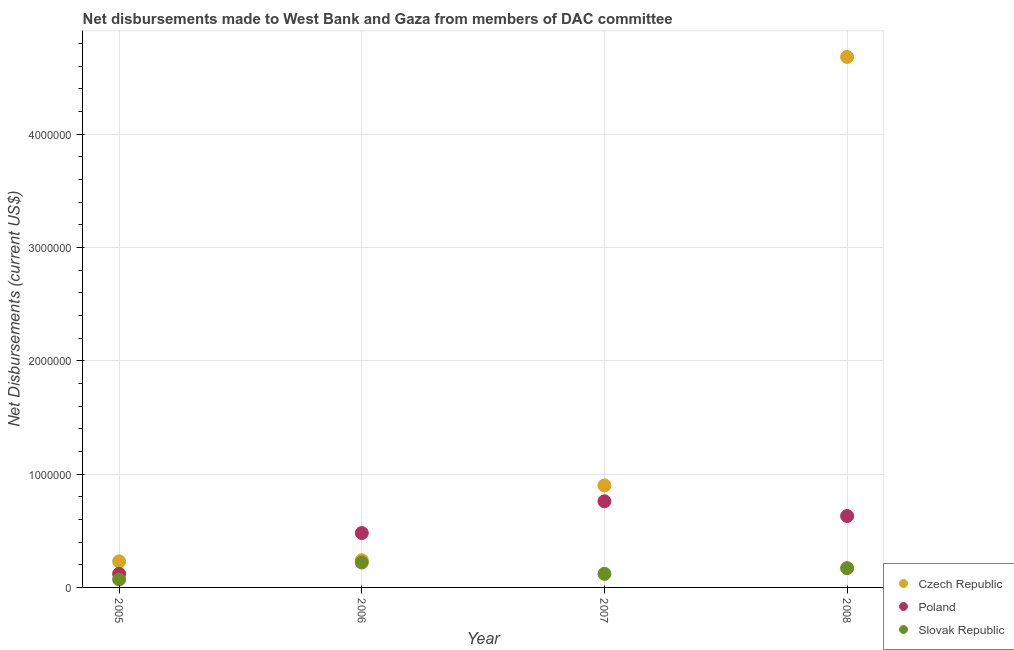How many different coloured dotlines are there?
Offer a very short reply. 3. Is the number of dotlines equal to the number of legend labels?
Offer a very short reply. Yes. What is the net disbursements made by slovak republic in 2006?
Keep it short and to the point. 2.20e+05. Across all years, what is the maximum net disbursements made by slovak republic?
Your answer should be compact. 2.20e+05. Across all years, what is the minimum net disbursements made by poland?
Offer a terse response. 1.20e+05. In which year was the net disbursements made by poland minimum?
Offer a terse response. 2005. What is the total net disbursements made by slovak republic in the graph?
Give a very brief answer. 5.80e+05. What is the difference between the net disbursements made by poland in 2007 and that in 2008?
Your response must be concise. 1.30e+05. What is the difference between the net disbursements made by czech republic in 2007 and the net disbursements made by poland in 2006?
Provide a short and direct response. 4.20e+05. What is the average net disbursements made by slovak republic per year?
Provide a succinct answer. 1.45e+05. In the year 2008, what is the difference between the net disbursements made by poland and net disbursements made by czech republic?
Give a very brief answer. -4.05e+06. What is the ratio of the net disbursements made by poland in 2005 to that in 2008?
Ensure brevity in your answer.  0.19. Is the net disbursements made by czech republic in 2005 less than that in 2008?
Give a very brief answer. Yes. Is the difference between the net disbursements made by czech republic in 2006 and 2007 greater than the difference between the net disbursements made by slovak republic in 2006 and 2007?
Offer a terse response. No. What is the difference between the highest and the second highest net disbursements made by poland?
Your answer should be compact. 1.30e+05. What is the difference between the highest and the lowest net disbursements made by czech republic?
Your response must be concise. 4.45e+06. Is the sum of the net disbursements made by czech republic in 2006 and 2007 greater than the maximum net disbursements made by poland across all years?
Offer a terse response. Yes. Is it the case that in every year, the sum of the net disbursements made by czech republic and net disbursements made by poland is greater than the net disbursements made by slovak republic?
Your answer should be compact. Yes. Does the net disbursements made by czech republic monotonically increase over the years?
Keep it short and to the point. Yes. Is the net disbursements made by czech republic strictly greater than the net disbursements made by slovak republic over the years?
Offer a terse response. Yes. How many years are there in the graph?
Keep it short and to the point. 4. Does the graph contain any zero values?
Your response must be concise. No. Does the graph contain grids?
Keep it short and to the point. Yes. Where does the legend appear in the graph?
Offer a very short reply. Bottom right. What is the title of the graph?
Give a very brief answer. Net disbursements made to West Bank and Gaza from members of DAC committee. What is the label or title of the Y-axis?
Make the answer very short. Net Disbursements (current US$). What is the Net Disbursements (current US$) of Slovak Republic in 2005?
Provide a short and direct response. 7.00e+04. What is the Net Disbursements (current US$) in Poland in 2006?
Offer a terse response. 4.80e+05. What is the Net Disbursements (current US$) of Slovak Republic in 2006?
Provide a short and direct response. 2.20e+05. What is the Net Disbursements (current US$) in Poland in 2007?
Keep it short and to the point. 7.60e+05. What is the Net Disbursements (current US$) of Czech Republic in 2008?
Your answer should be compact. 4.68e+06. What is the Net Disbursements (current US$) in Poland in 2008?
Provide a succinct answer. 6.30e+05. What is the Net Disbursements (current US$) in Slovak Republic in 2008?
Offer a very short reply. 1.70e+05. Across all years, what is the maximum Net Disbursements (current US$) in Czech Republic?
Offer a very short reply. 4.68e+06. Across all years, what is the maximum Net Disbursements (current US$) of Poland?
Provide a succinct answer. 7.60e+05. Across all years, what is the maximum Net Disbursements (current US$) in Slovak Republic?
Offer a very short reply. 2.20e+05. Across all years, what is the minimum Net Disbursements (current US$) of Czech Republic?
Provide a short and direct response. 2.30e+05. Across all years, what is the minimum Net Disbursements (current US$) of Poland?
Offer a terse response. 1.20e+05. Across all years, what is the minimum Net Disbursements (current US$) in Slovak Republic?
Ensure brevity in your answer.  7.00e+04. What is the total Net Disbursements (current US$) in Czech Republic in the graph?
Provide a succinct answer. 6.05e+06. What is the total Net Disbursements (current US$) in Poland in the graph?
Your response must be concise. 1.99e+06. What is the total Net Disbursements (current US$) in Slovak Republic in the graph?
Give a very brief answer. 5.80e+05. What is the difference between the Net Disbursements (current US$) of Czech Republic in 2005 and that in 2006?
Offer a very short reply. -10000. What is the difference between the Net Disbursements (current US$) in Poland in 2005 and that in 2006?
Your response must be concise. -3.60e+05. What is the difference between the Net Disbursements (current US$) of Czech Republic in 2005 and that in 2007?
Offer a terse response. -6.70e+05. What is the difference between the Net Disbursements (current US$) of Poland in 2005 and that in 2007?
Keep it short and to the point. -6.40e+05. What is the difference between the Net Disbursements (current US$) in Czech Republic in 2005 and that in 2008?
Keep it short and to the point. -4.45e+06. What is the difference between the Net Disbursements (current US$) in Poland in 2005 and that in 2008?
Ensure brevity in your answer.  -5.10e+05. What is the difference between the Net Disbursements (current US$) of Czech Republic in 2006 and that in 2007?
Keep it short and to the point. -6.60e+05. What is the difference between the Net Disbursements (current US$) in Poland in 2006 and that in 2007?
Give a very brief answer. -2.80e+05. What is the difference between the Net Disbursements (current US$) of Czech Republic in 2006 and that in 2008?
Provide a short and direct response. -4.44e+06. What is the difference between the Net Disbursements (current US$) of Czech Republic in 2007 and that in 2008?
Offer a terse response. -3.78e+06. What is the difference between the Net Disbursements (current US$) of Poland in 2005 and the Net Disbursements (current US$) of Slovak Republic in 2006?
Provide a short and direct response. -1.00e+05. What is the difference between the Net Disbursements (current US$) in Czech Republic in 2005 and the Net Disbursements (current US$) in Poland in 2007?
Provide a short and direct response. -5.30e+05. What is the difference between the Net Disbursements (current US$) of Poland in 2005 and the Net Disbursements (current US$) of Slovak Republic in 2007?
Keep it short and to the point. 0. What is the difference between the Net Disbursements (current US$) in Czech Republic in 2005 and the Net Disbursements (current US$) in Poland in 2008?
Your answer should be compact. -4.00e+05. What is the difference between the Net Disbursements (current US$) of Czech Republic in 2005 and the Net Disbursements (current US$) of Slovak Republic in 2008?
Provide a succinct answer. 6.00e+04. What is the difference between the Net Disbursements (current US$) in Poland in 2005 and the Net Disbursements (current US$) in Slovak Republic in 2008?
Provide a short and direct response. -5.00e+04. What is the difference between the Net Disbursements (current US$) of Czech Republic in 2006 and the Net Disbursements (current US$) of Poland in 2007?
Offer a very short reply. -5.20e+05. What is the difference between the Net Disbursements (current US$) in Poland in 2006 and the Net Disbursements (current US$) in Slovak Republic in 2007?
Your answer should be very brief. 3.60e+05. What is the difference between the Net Disbursements (current US$) in Czech Republic in 2006 and the Net Disbursements (current US$) in Poland in 2008?
Provide a succinct answer. -3.90e+05. What is the difference between the Net Disbursements (current US$) of Czech Republic in 2007 and the Net Disbursements (current US$) of Poland in 2008?
Make the answer very short. 2.70e+05. What is the difference between the Net Disbursements (current US$) in Czech Republic in 2007 and the Net Disbursements (current US$) in Slovak Republic in 2008?
Keep it short and to the point. 7.30e+05. What is the difference between the Net Disbursements (current US$) of Poland in 2007 and the Net Disbursements (current US$) of Slovak Republic in 2008?
Give a very brief answer. 5.90e+05. What is the average Net Disbursements (current US$) of Czech Republic per year?
Your answer should be compact. 1.51e+06. What is the average Net Disbursements (current US$) of Poland per year?
Your answer should be compact. 4.98e+05. What is the average Net Disbursements (current US$) in Slovak Republic per year?
Provide a succinct answer. 1.45e+05. In the year 2005, what is the difference between the Net Disbursements (current US$) of Czech Republic and Net Disbursements (current US$) of Slovak Republic?
Give a very brief answer. 1.60e+05. In the year 2005, what is the difference between the Net Disbursements (current US$) of Poland and Net Disbursements (current US$) of Slovak Republic?
Offer a terse response. 5.00e+04. In the year 2006, what is the difference between the Net Disbursements (current US$) of Czech Republic and Net Disbursements (current US$) of Poland?
Your response must be concise. -2.40e+05. In the year 2006, what is the difference between the Net Disbursements (current US$) in Czech Republic and Net Disbursements (current US$) in Slovak Republic?
Your answer should be compact. 2.00e+04. In the year 2006, what is the difference between the Net Disbursements (current US$) in Poland and Net Disbursements (current US$) in Slovak Republic?
Your response must be concise. 2.60e+05. In the year 2007, what is the difference between the Net Disbursements (current US$) in Czech Republic and Net Disbursements (current US$) in Slovak Republic?
Make the answer very short. 7.80e+05. In the year 2007, what is the difference between the Net Disbursements (current US$) of Poland and Net Disbursements (current US$) of Slovak Republic?
Make the answer very short. 6.40e+05. In the year 2008, what is the difference between the Net Disbursements (current US$) in Czech Republic and Net Disbursements (current US$) in Poland?
Your answer should be compact. 4.05e+06. In the year 2008, what is the difference between the Net Disbursements (current US$) of Czech Republic and Net Disbursements (current US$) of Slovak Republic?
Your answer should be compact. 4.51e+06. In the year 2008, what is the difference between the Net Disbursements (current US$) in Poland and Net Disbursements (current US$) in Slovak Republic?
Keep it short and to the point. 4.60e+05. What is the ratio of the Net Disbursements (current US$) of Czech Republic in 2005 to that in 2006?
Ensure brevity in your answer.  0.96. What is the ratio of the Net Disbursements (current US$) in Poland in 2005 to that in 2006?
Keep it short and to the point. 0.25. What is the ratio of the Net Disbursements (current US$) in Slovak Republic in 2005 to that in 2006?
Your answer should be very brief. 0.32. What is the ratio of the Net Disbursements (current US$) of Czech Republic in 2005 to that in 2007?
Give a very brief answer. 0.26. What is the ratio of the Net Disbursements (current US$) in Poland in 2005 to that in 2007?
Your answer should be compact. 0.16. What is the ratio of the Net Disbursements (current US$) of Slovak Republic in 2005 to that in 2007?
Your answer should be very brief. 0.58. What is the ratio of the Net Disbursements (current US$) of Czech Republic in 2005 to that in 2008?
Offer a very short reply. 0.05. What is the ratio of the Net Disbursements (current US$) in Poland in 2005 to that in 2008?
Give a very brief answer. 0.19. What is the ratio of the Net Disbursements (current US$) of Slovak Republic in 2005 to that in 2008?
Offer a terse response. 0.41. What is the ratio of the Net Disbursements (current US$) of Czech Republic in 2006 to that in 2007?
Your answer should be compact. 0.27. What is the ratio of the Net Disbursements (current US$) of Poland in 2006 to that in 2007?
Offer a very short reply. 0.63. What is the ratio of the Net Disbursements (current US$) in Slovak Republic in 2006 to that in 2007?
Provide a succinct answer. 1.83. What is the ratio of the Net Disbursements (current US$) in Czech Republic in 2006 to that in 2008?
Give a very brief answer. 0.05. What is the ratio of the Net Disbursements (current US$) of Poland in 2006 to that in 2008?
Your answer should be very brief. 0.76. What is the ratio of the Net Disbursements (current US$) of Slovak Republic in 2006 to that in 2008?
Provide a succinct answer. 1.29. What is the ratio of the Net Disbursements (current US$) in Czech Republic in 2007 to that in 2008?
Your answer should be compact. 0.19. What is the ratio of the Net Disbursements (current US$) of Poland in 2007 to that in 2008?
Give a very brief answer. 1.21. What is the ratio of the Net Disbursements (current US$) in Slovak Republic in 2007 to that in 2008?
Provide a succinct answer. 0.71. What is the difference between the highest and the second highest Net Disbursements (current US$) of Czech Republic?
Your response must be concise. 3.78e+06. What is the difference between the highest and the lowest Net Disbursements (current US$) of Czech Republic?
Offer a very short reply. 4.45e+06. What is the difference between the highest and the lowest Net Disbursements (current US$) in Poland?
Provide a succinct answer. 6.40e+05. 